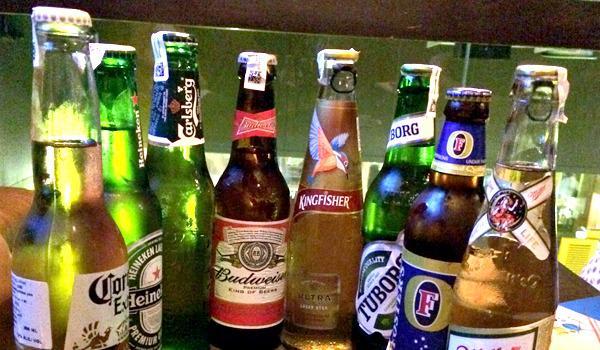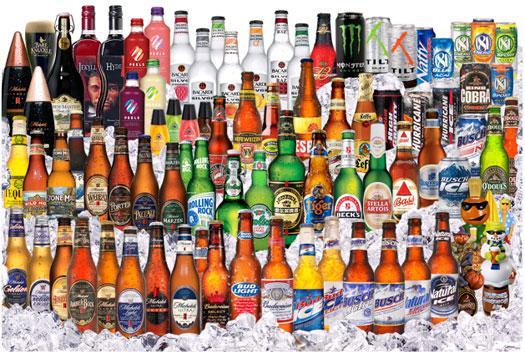The first image is the image on the left, the second image is the image on the right. Considering the images on both sides, is "One of the images includes fewer than eight bottles in total." valid? Answer yes or no. No. 